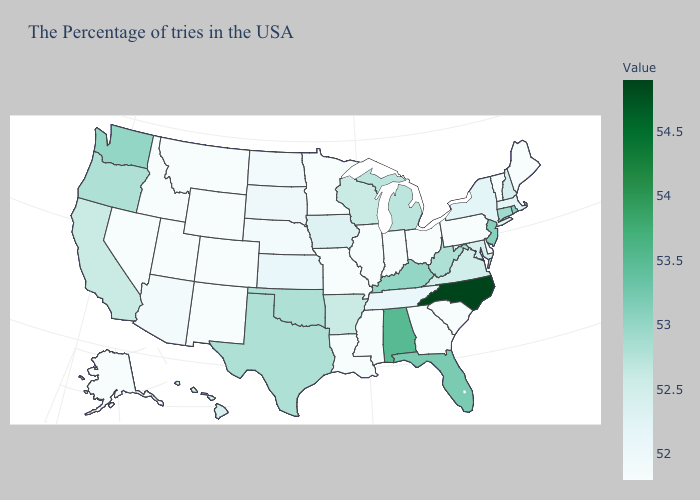Which states have the lowest value in the USA?
Short answer required. Maine, Vermont, Delaware, Pennsylvania, South Carolina, Ohio, Georgia, Indiana, Illinois, Mississippi, Louisiana, Missouri, Minnesota, Wyoming, Colorado, New Mexico, Utah, Montana, Idaho, Nevada, Alaska. Does Iowa have the lowest value in the MidWest?
Concise answer only. No. Among the states that border Georgia , does North Carolina have the highest value?
Short answer required. Yes. Which states hav the highest value in the South?
Short answer required. North Carolina. Does New Hampshire have the lowest value in the USA?
Answer briefly. No. Does Massachusetts have the highest value in the Northeast?
Give a very brief answer. No. Does Nebraska have a higher value than Connecticut?
Keep it brief. No. Among the states that border Nevada , which have the highest value?
Keep it brief. Oregon. Does Kentucky have a lower value than Nevada?
Short answer required. No. Does Delaware have the highest value in the South?
Short answer required. No. Is the legend a continuous bar?
Be succinct. Yes. 